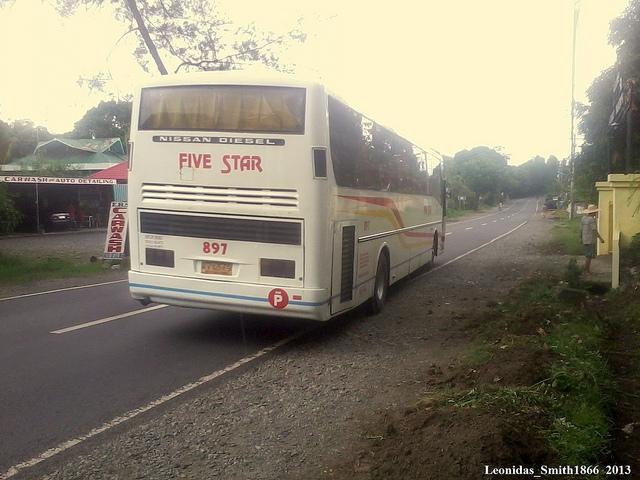The D word here refers to what?
Indicate the correct response and explain using: 'Answer: answer
Rationale: rationale.'
Options: Route, brand, location, fuel. Answer: fuel.
Rationale: The d word is fuel. 